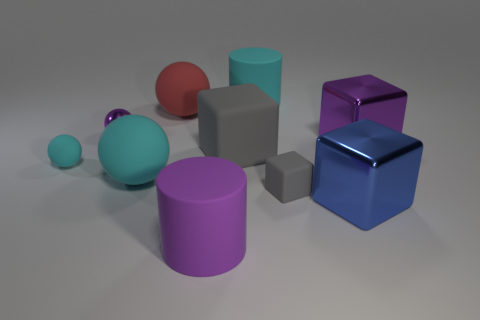Subtract 1 blocks. How many blocks are left? 3 Subtract all cylinders. How many objects are left? 8 Add 3 big gray matte blocks. How many big gray matte blocks exist? 4 Subtract 1 blue cubes. How many objects are left? 9 Subtract all gray things. Subtract all tiny blocks. How many objects are left? 7 Add 3 purple objects. How many purple objects are left? 6 